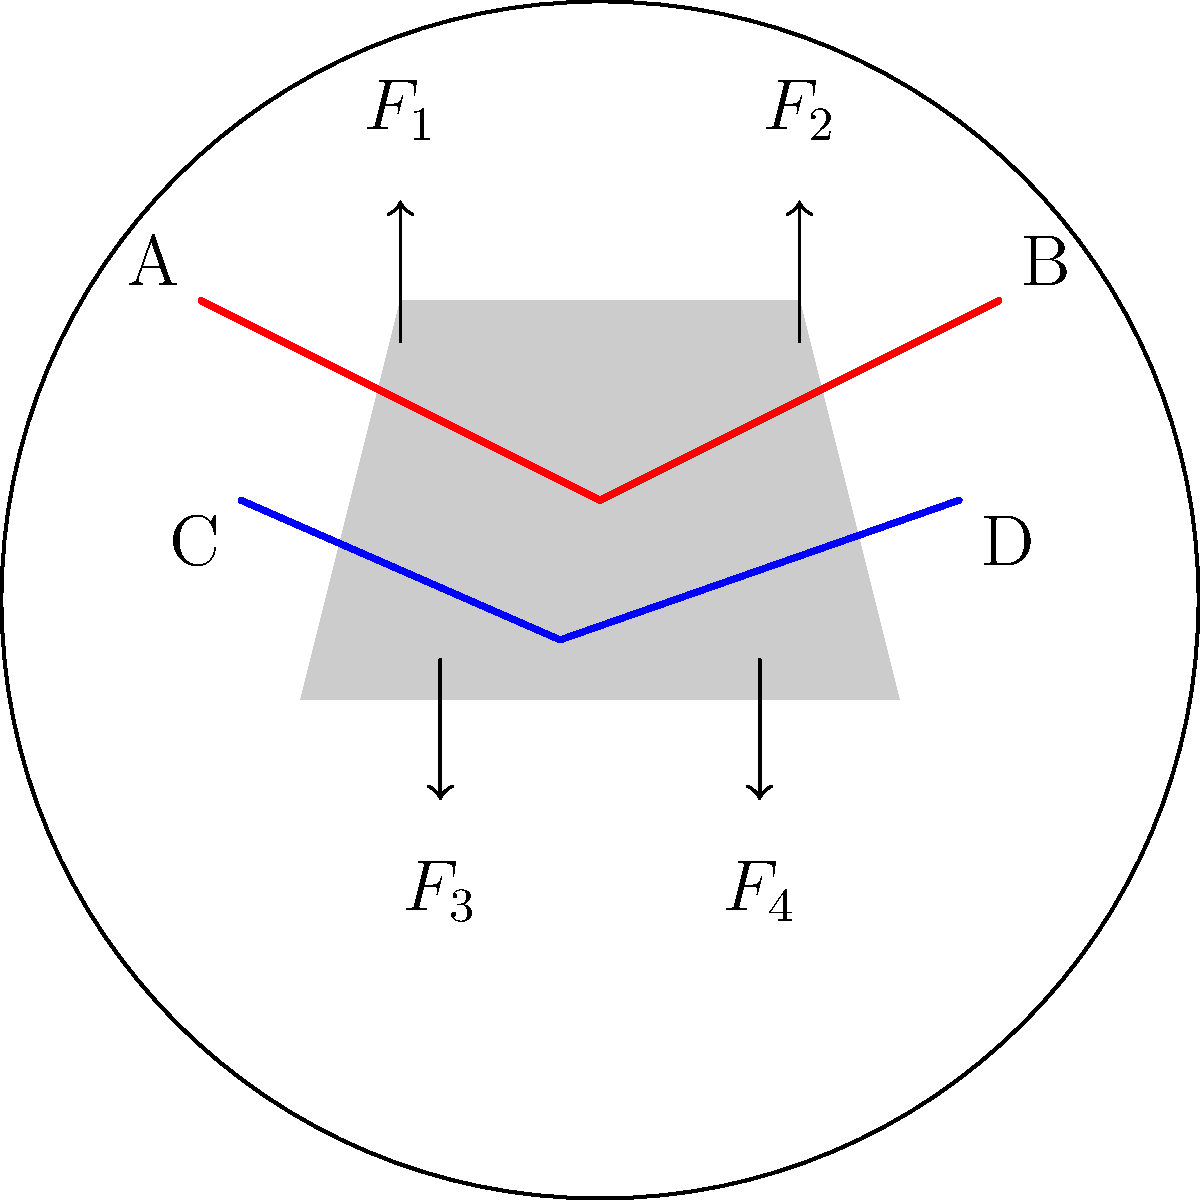In the diagram above, a potter's hands are shown during the wheel throwing process. The upper hands (A and B) apply forces $F_1$ and $F_2$ downward, while the lower hands (C and D) apply forces $F_3$ and $F_4$ upward. If the clay remains stable and centered on the wheel, what is the relationship between these forces? To answer this question, we need to consider the principles of force equilibrium in biomechanics:

1. For an object to remain stable and centered, the sum of all forces acting on it must be zero.

2. In this case, we have four forces acting on the clay:
   - $F_1$ and $F_2$ pushing downward
   - $F_3$ and $F_4$ pushing upward

3. To maintain equilibrium in the vertical direction:
   $F_1 + F_2 = F_3 + F_4$

4. Additionally, for the clay to remain centered, the horizontal components of these forces must also balance out. However, this is not explicitly asked in the question.

5. Therefore, the total downward force must equal the total upward force for the clay to remain stable and centered on the wheel.
Answer: $F_1 + F_2 = F_3 + F_4$ 